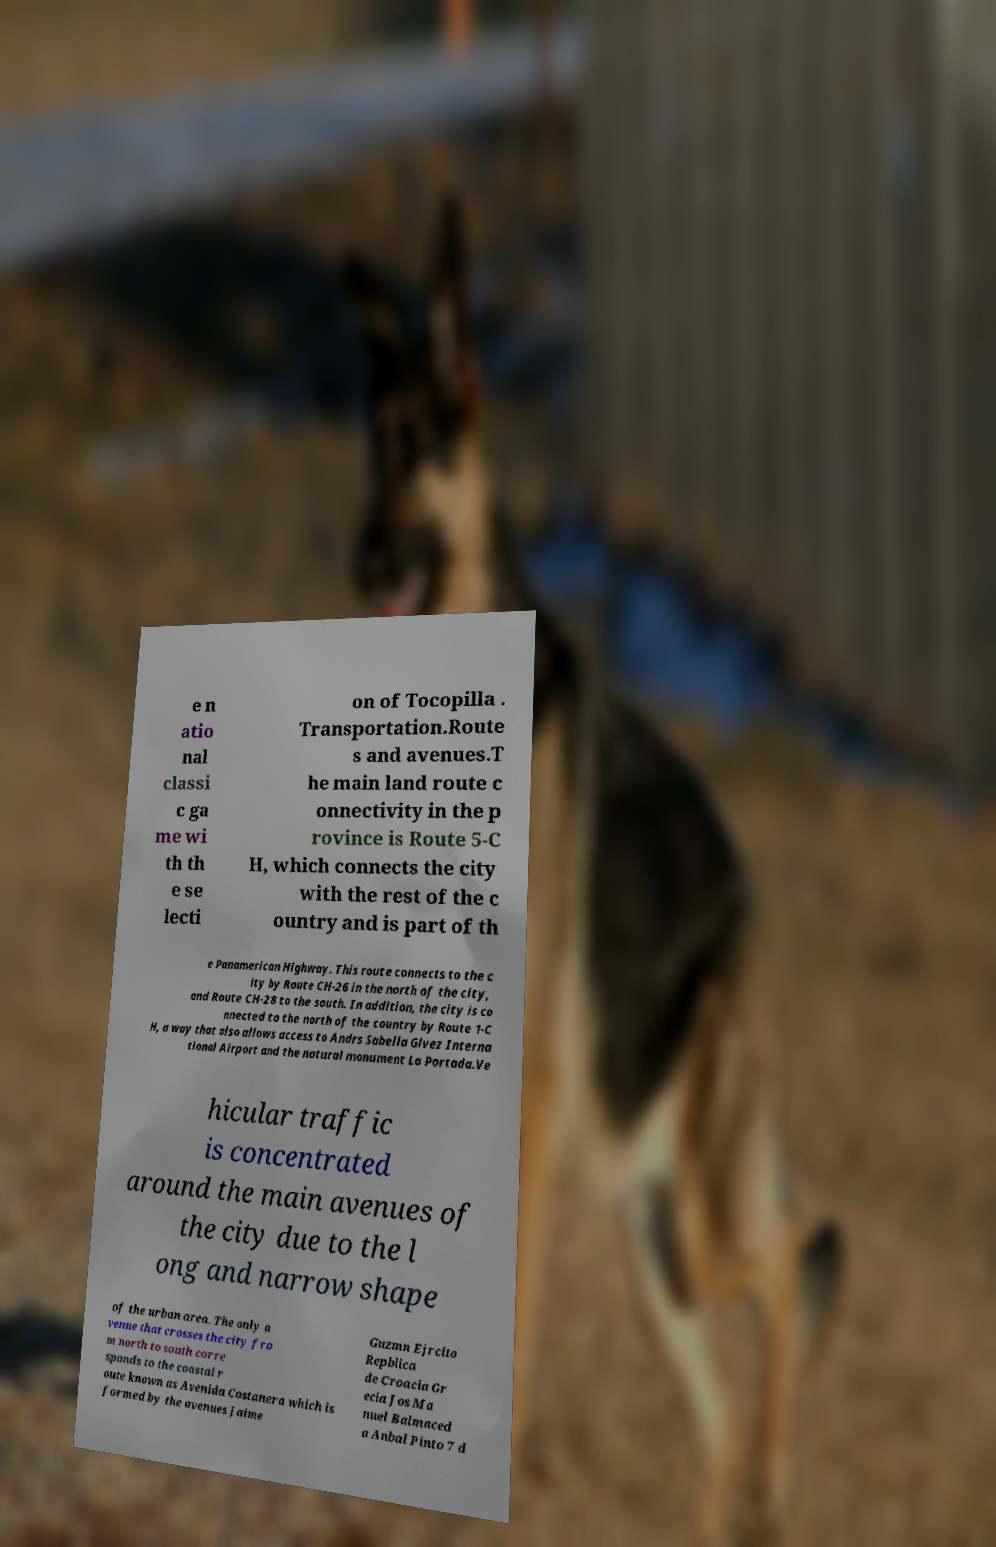Could you extract and type out the text from this image? e n atio nal classi c ga me wi th th e se lecti on of Tocopilla . Transportation.Route s and avenues.T he main land route c onnectivity in the p rovince is Route 5-C H, which connects the city with the rest of the c ountry and is part of th e Panamerican Highway. This route connects to the c ity by Route CH-26 in the north of the city, and Route CH-28 to the south. In addition, the city is co nnected to the north of the country by Route 1-C H, a way that also allows access to Andrs Sabella Glvez Interna tional Airport and the natural monument La Portada.Ve hicular traffic is concentrated around the main avenues of the city due to the l ong and narrow shape of the urban area. The only a venue that crosses the city fro m north to south corre sponds to the coastal r oute known as Avenida Costanera which is formed by the avenues Jaime Guzmn Ejrcito Repblica de Croacia Gr ecia Jos Ma nuel Balmaced a Anbal Pinto 7 d 